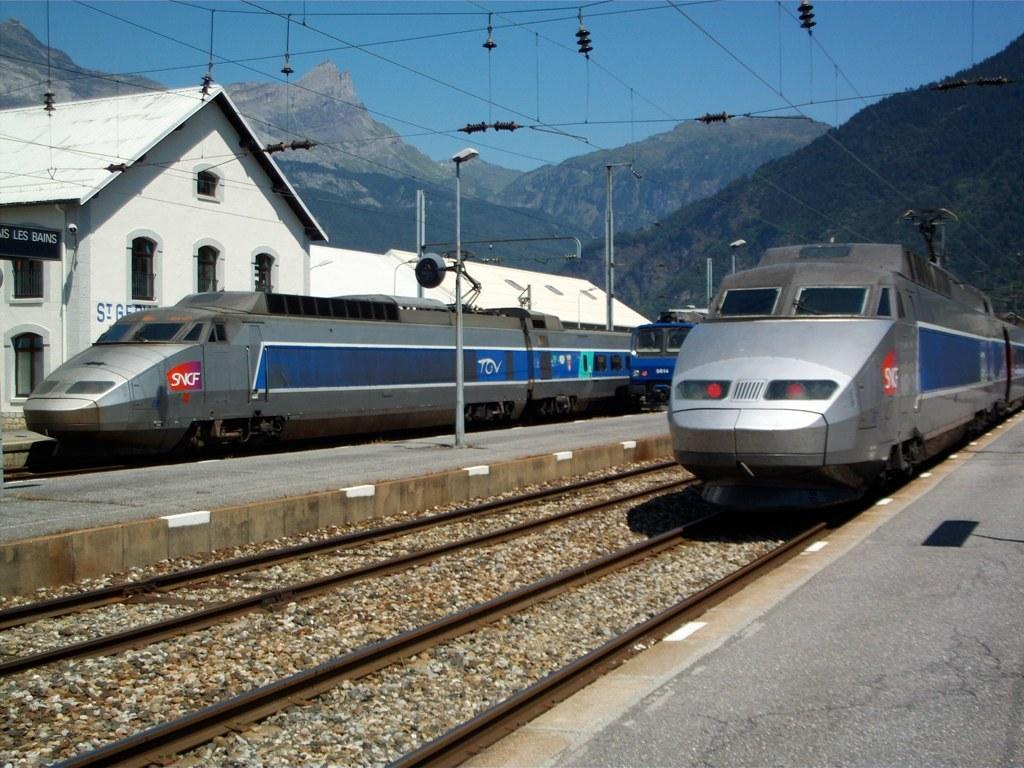What can be seen traveling on the railway track in the image? There are trains on the railway track in the image. What structures are present alongside the railway track? There are poles in the image. What is connected to the poles in the image? Electric wires are present in the image. What can be seen in the background of the image? There is a house and mountains visible in the background of the image. What else is visible in the background of the image? The sky is visible in the background of the image. What type of knowledge can be gained from the trains' voice in the image? There is no indication in the image that the trains have a voice or can impart knowledge. 